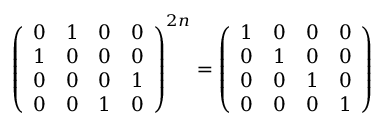<formula> <loc_0><loc_0><loc_500><loc_500>\left ( \begin{array} { c c c c } { 0 } & { 1 } & { 0 } & { 0 } \\ { 1 } & { 0 } & { 0 } & { 0 } \\ { 0 } & { 0 } & { 0 } & { 1 } \\ { 0 } & { 0 } & { 1 } & { 0 } \end{array} \right ) ^ { 2 n } = \left ( \begin{array} { c c c c } { 1 } & { 0 } & { 0 } & { 0 } \\ { 0 } & { 1 } & { 0 } & { 0 } \\ { 0 } & { 0 } & { 1 } & { 0 } \\ { 0 } & { 0 } & { 0 } & { 1 } \end{array} \right )</formula> 